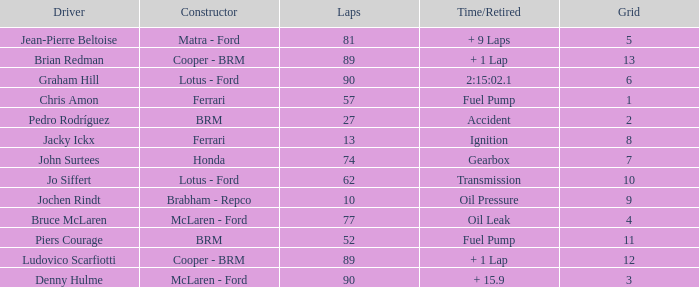What is the time/retired when the laps is 52? Fuel Pump. 